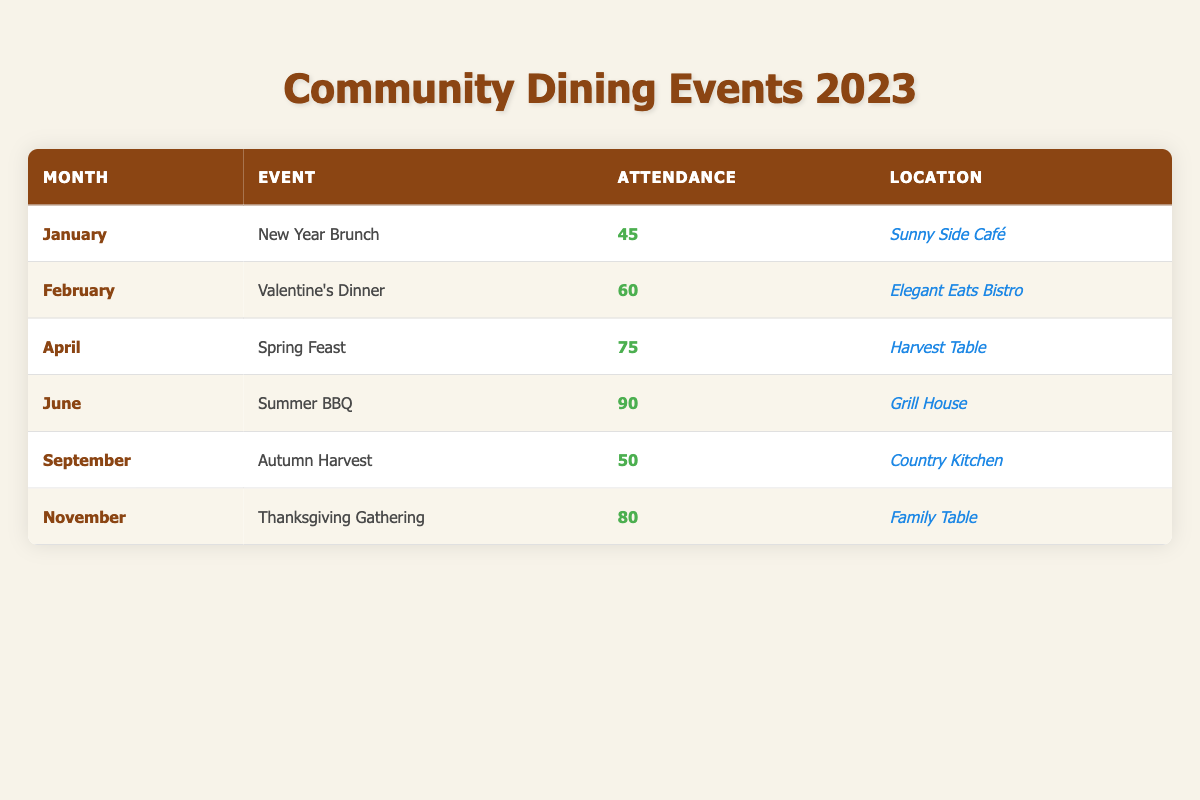What is the attendance at the Valentine's Dinner? The table shows the attendance number for each event. For the month of February, the event is Valentine's Dinner with an attendance of 60.
Answer: 60 Which event had the highest attendance? The attendance numbers for each event can be compared. Summer BBQ in June has the highest attendance at 90.
Answer: Summer BBQ What is the average attendance across all listed events? The attendance figures are: 45, 60, 75, 90, 50, and 80. Summing these gives 400, and dividing by the number of events (6) results in an average attendance of 400/6 = 66.67.
Answer: 66.67 Did the Autumn Harvest have more attendees than the Thanksgiving Gathering? The attendance for Autumn Harvest is 50, while Thanksgiving Gathering has 80. Comparing these values shows that 50 is less than 80, so the statement is false.
Answer: No In which month did the New Year Brunch take place? The table indicates that New Year Brunch was held in January.
Answer: January What is the total attendance for all events from April to November? The attendance from April (75), June (90), September (50), and November (80) must be summed: 75 + 90 + 50 + 80 = 295.
Answer: 295 What month had the least attendance? The attendance numbers for each month are: January (45), February (60), April (75), June (90), September (50), and November (80). The lowest attendance is found in January, with 45.
Answer: January Is it true that every event has an attendance of at least 50? Checking the attendance numbers: January (45) is below 50, hence not all events meet this criterion.
Answer: No What was the second-highest attendance number, and which event corresponds to that attendance? The attendance ranking from highest to lowest is: Summer BBQ (90), Thanksgiving Gathering (80), Spring Feast (75). The second-highest attendance is 80, corresponding to the Thanksgiving Gathering.
Answer: 80, Thanksgiving Gathering 